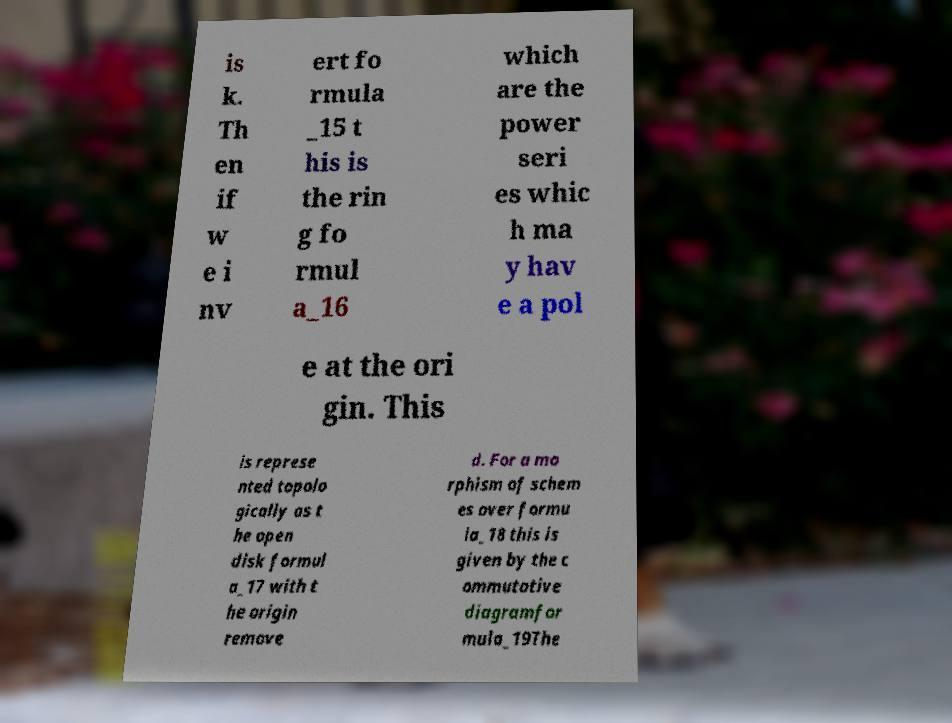There's text embedded in this image that I need extracted. Can you transcribe it verbatim? is k. Th en if w e i nv ert fo rmula _15 t his is the rin g fo rmul a_16 which are the power seri es whic h ma y hav e a pol e at the ori gin. This is represe nted topolo gically as t he open disk formul a_17 with t he origin remove d. For a mo rphism of schem es over formu la_18 this is given by the c ommutative diagramfor mula_19The 